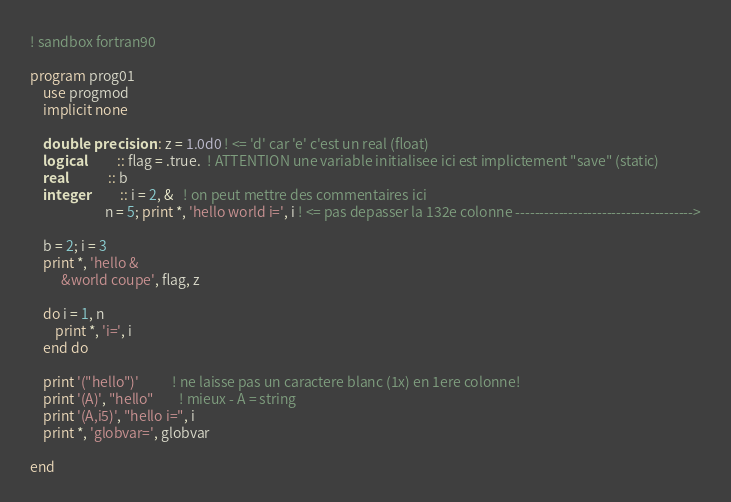<code> <loc_0><loc_0><loc_500><loc_500><_FORTRAN_>! sandbox fortran90

program prog01
    use progmod
    implicit none

    double precision :: z = 1.0d0 ! <= 'd' car 'e' c'est un real (float)
    logical          :: flag = .true.  ! ATTENTION une variable initialisee ici est implictement "save" (static)
    real             :: b
    integer          :: i = 2, &   ! on peut mettre des commentaires ici
                        n = 5; print *, 'hello world i=', i ! <= pas depasser la 132e colonne ------------------------------------->

    b = 2; i = 3
    print *, 'hello &
          &world coupe', flag, z

    do i = 1, n
        print *, 'i=', i
    end do

    print '("hello")'           ! ne laisse pas un caractere blanc (1x) en 1ere colonne!
    print '(A)', "hello"        ! mieux - A = string
    print '(A,i5)', "hello i=", i
    print *, 'globvar=', globvar

end
</code> 